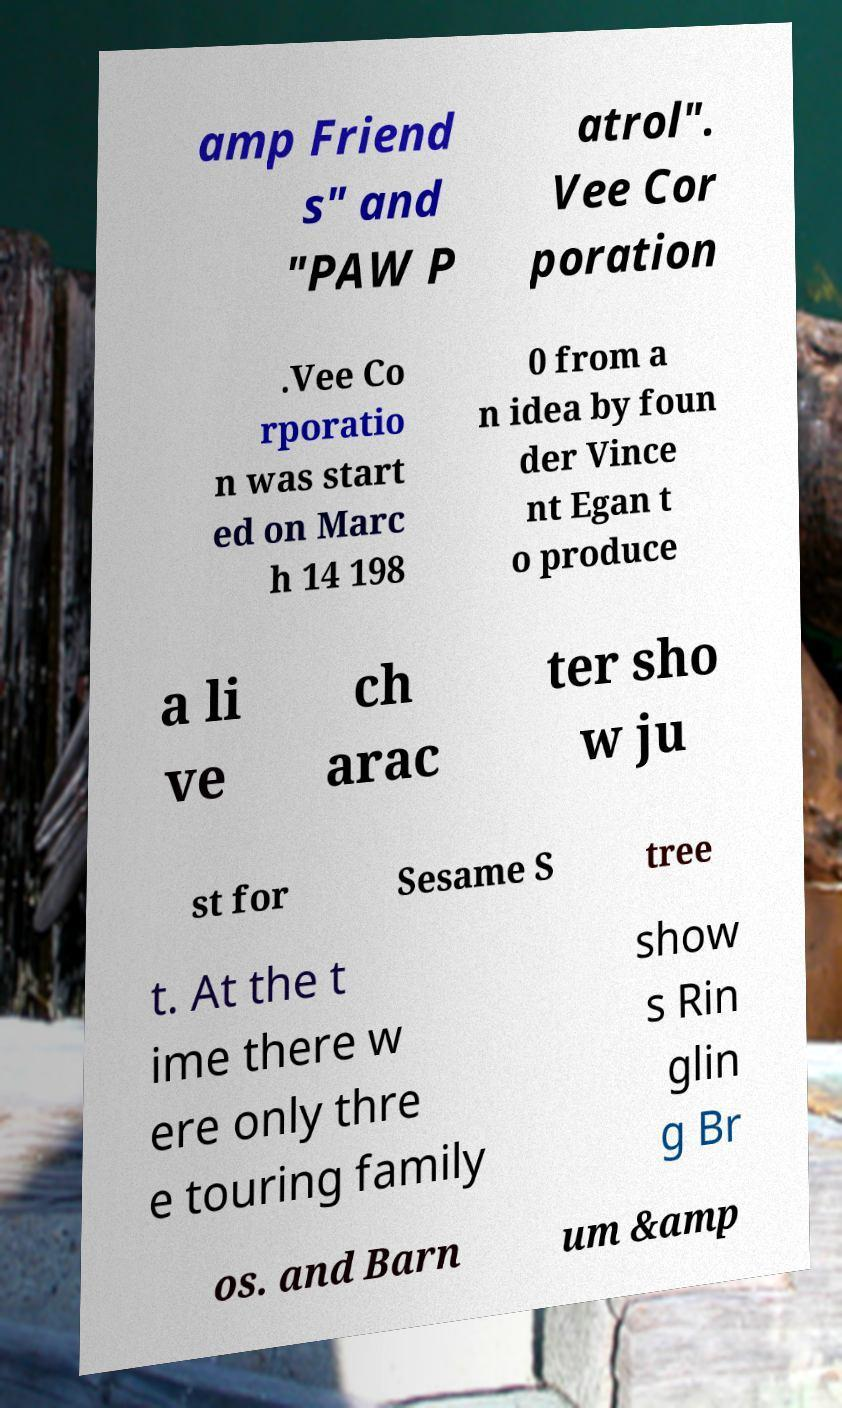Can you read and provide the text displayed in the image?This photo seems to have some interesting text. Can you extract and type it out for me? amp Friend s" and "PAW P atrol". Vee Cor poration .Vee Co rporatio n was start ed on Marc h 14 198 0 from a n idea by foun der Vince nt Egan t o produce a li ve ch arac ter sho w ju st for Sesame S tree t. At the t ime there w ere only thre e touring family show s Rin glin g Br os. and Barn um &amp 